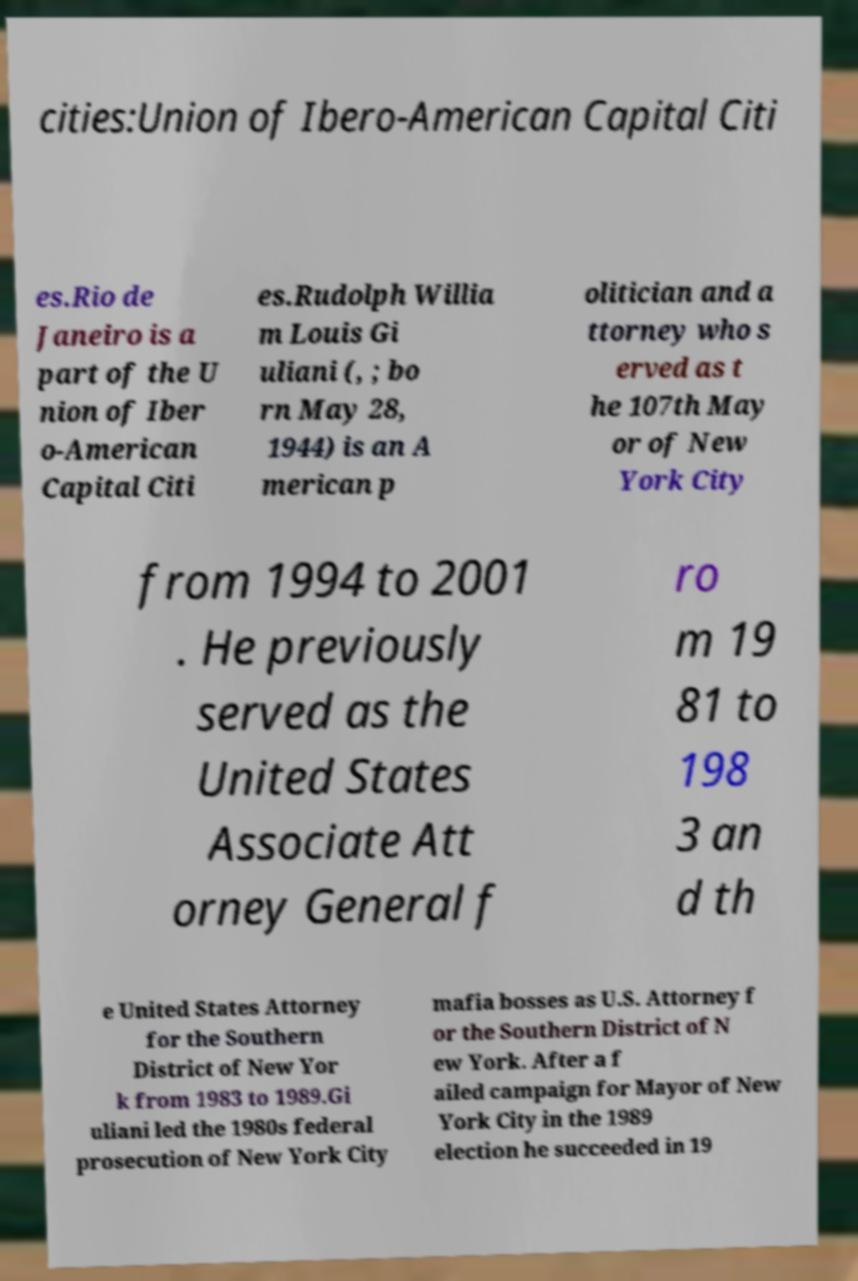I need the written content from this picture converted into text. Can you do that? cities:Union of Ibero-American Capital Citi es.Rio de Janeiro is a part of the U nion of Iber o-American Capital Citi es.Rudolph Willia m Louis Gi uliani (, ; bo rn May 28, 1944) is an A merican p olitician and a ttorney who s erved as t he 107th May or of New York City from 1994 to 2001 . He previously served as the United States Associate Att orney General f ro m 19 81 to 198 3 an d th e United States Attorney for the Southern District of New Yor k from 1983 to 1989.Gi uliani led the 1980s federal prosecution of New York City mafia bosses as U.S. Attorney f or the Southern District of N ew York. After a f ailed campaign for Mayor of New York City in the 1989 election he succeeded in 19 